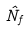Convert formula to latex. <formula><loc_0><loc_0><loc_500><loc_500>\hat { N } _ { f }</formula> 